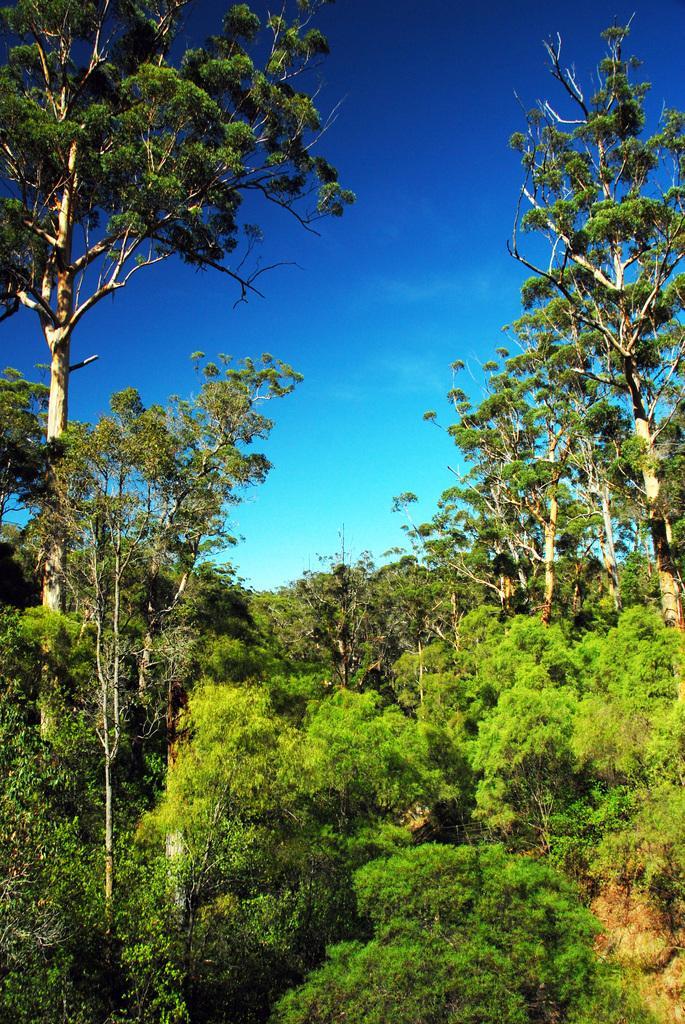Please provide a concise description of this image. In this image I can see a forest , in the forest I can see trees and the sky visible. 